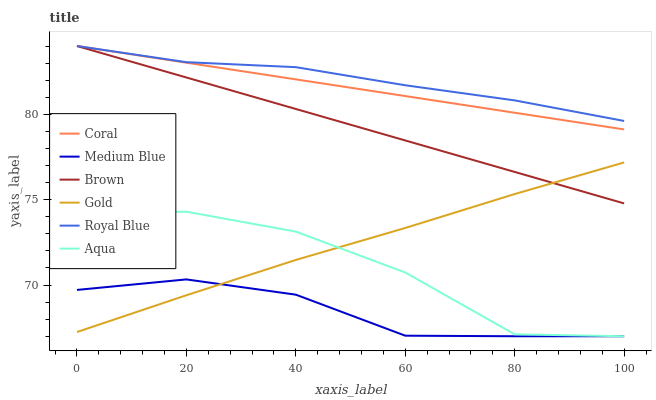Does Medium Blue have the minimum area under the curve?
Answer yes or no. Yes. Does Royal Blue have the maximum area under the curve?
Answer yes or no. Yes. Does Gold have the minimum area under the curve?
Answer yes or no. No. Does Gold have the maximum area under the curve?
Answer yes or no. No. Is Brown the smoothest?
Answer yes or no. Yes. Is Aqua the roughest?
Answer yes or no. Yes. Is Gold the smoothest?
Answer yes or no. No. Is Gold the roughest?
Answer yes or no. No. Does Medium Blue have the lowest value?
Answer yes or no. Yes. Does Gold have the lowest value?
Answer yes or no. No. Does Royal Blue have the highest value?
Answer yes or no. Yes. Does Gold have the highest value?
Answer yes or no. No. Is Aqua less than Coral?
Answer yes or no. Yes. Is Brown greater than Aqua?
Answer yes or no. Yes. Does Gold intersect Aqua?
Answer yes or no. Yes. Is Gold less than Aqua?
Answer yes or no. No. Is Gold greater than Aqua?
Answer yes or no. No. Does Aqua intersect Coral?
Answer yes or no. No. 